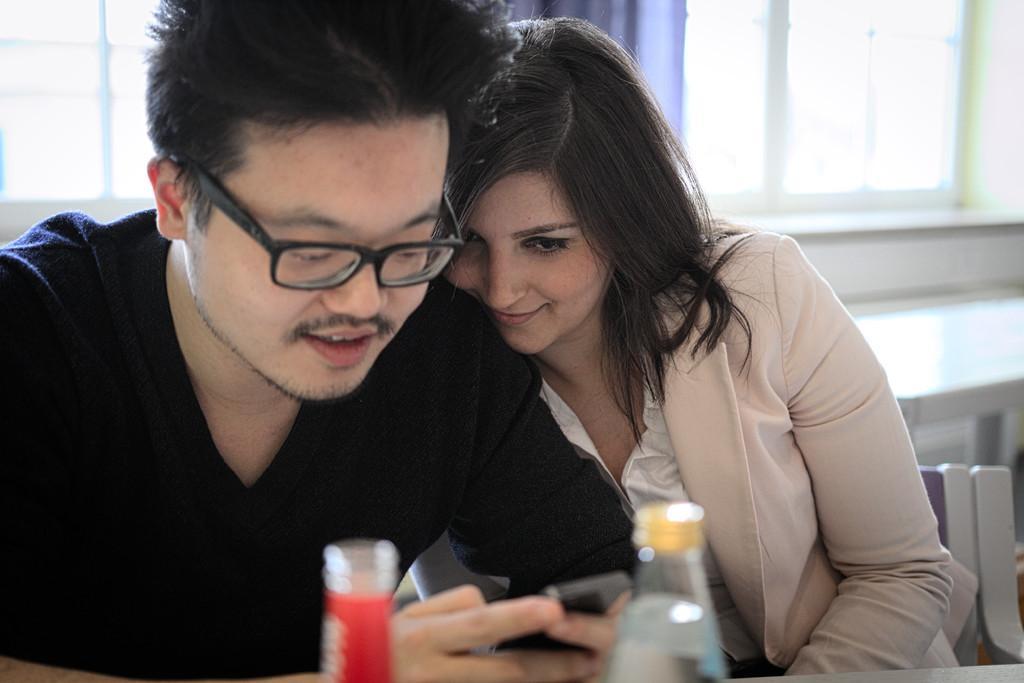Can you describe this image briefly? These two persons sitting on the chair. This person holding mobile. We can see bottle. On the background we can see window. 